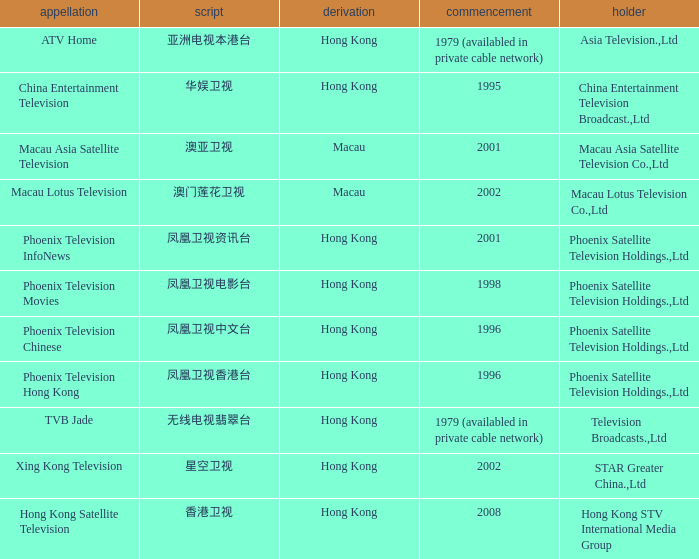What is the Hanzi of Phoenix Television Chinese that launched in 1996? 凤凰卫视中文台. 